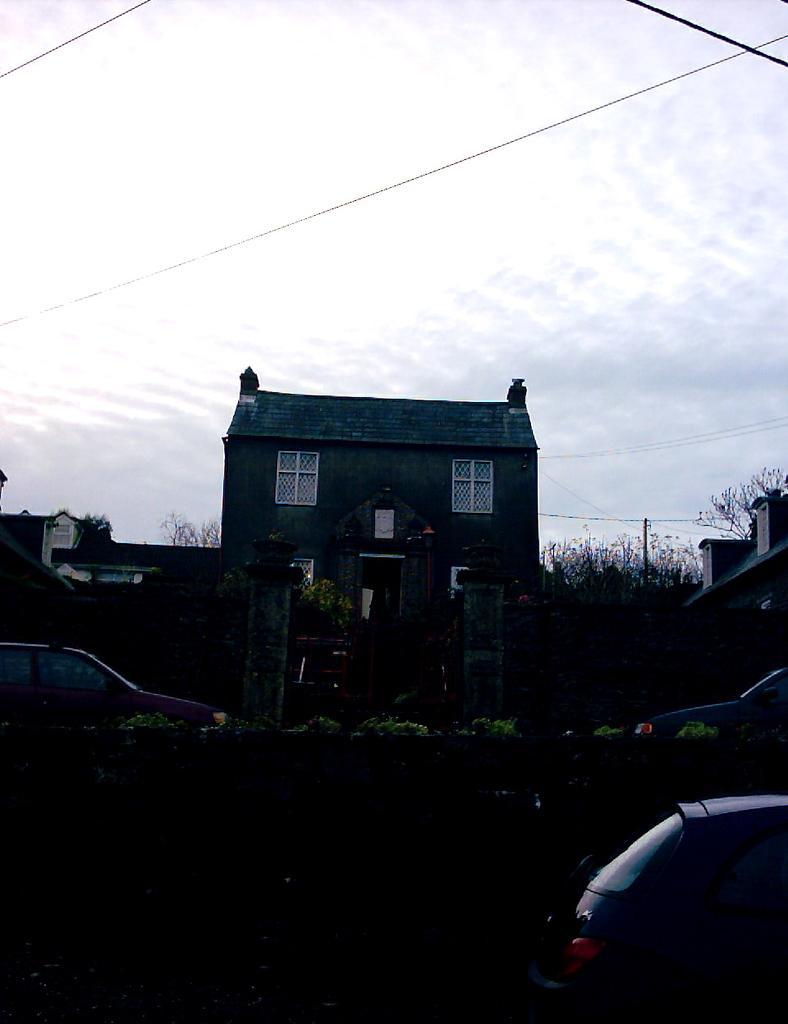How would you summarize this image in a sentence or two? In this image, we can see a building. There is a car on the left and on the bottom right of the image. There is a sky at the top of the image. 